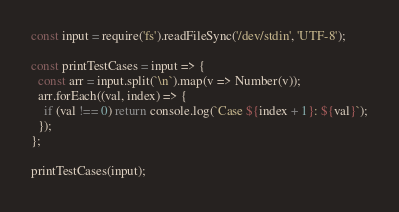Convert code to text. <code><loc_0><loc_0><loc_500><loc_500><_JavaScript_>const input = require('fs').readFileSync('/dev/stdin', 'UTF-8');

const printTestCases = input => {
  const arr = input.split(`\n`).map(v => Number(v));
  arr.forEach((val, index) => {
    if (val !== 0) return console.log(`Case ${index + 1}: ${val}`);
  });
};

printTestCases(input);

</code> 